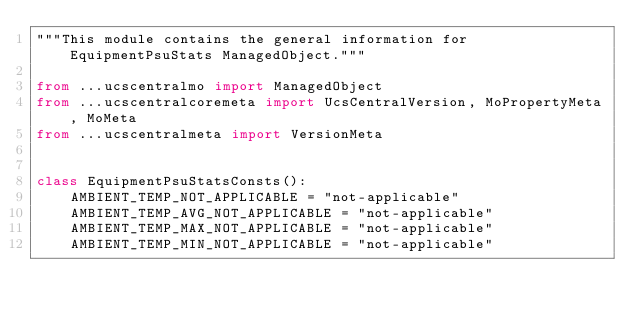<code> <loc_0><loc_0><loc_500><loc_500><_Python_>"""This module contains the general information for EquipmentPsuStats ManagedObject."""

from ...ucscentralmo import ManagedObject
from ...ucscentralcoremeta import UcsCentralVersion, MoPropertyMeta, MoMeta
from ...ucscentralmeta import VersionMeta


class EquipmentPsuStatsConsts():
    AMBIENT_TEMP_NOT_APPLICABLE = "not-applicable"
    AMBIENT_TEMP_AVG_NOT_APPLICABLE = "not-applicable"
    AMBIENT_TEMP_MAX_NOT_APPLICABLE = "not-applicable"
    AMBIENT_TEMP_MIN_NOT_APPLICABLE = "not-applicable"</code> 